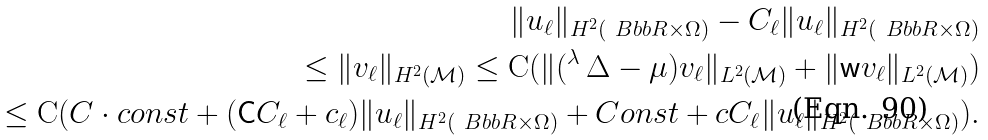<formula> <loc_0><loc_0><loc_500><loc_500>\| u _ { \ell } \| _ { H ^ { 2 } ( \ B b b R \times \Omega ) } - C _ { \ell } \| u _ { \ell } \| _ { H ^ { 2 } ( \ B b b R \times \Omega ) } \\ \leq \| v _ { \ell } \| _ { H ^ { 2 } ( \mathcal { M } ) } \leq \mathrm C ( \| ( { ^ { \lambda } \, \Delta } - \mu ) v _ { \ell } \| _ { L ^ { 2 } ( \mathcal { M } ) } + \| \mathsf w v _ { \ell } \| _ { L ^ { 2 } ( \mathcal { M } ) } ) \\ \leq \mathrm C ( C \cdot c o n s t + ( \mathsf C C _ { \ell } + c _ { \ell } ) \| u _ { \ell } \| _ { H ^ { 2 } ( \ B b b R \times \Omega ) } + C o n s t + c C _ { \ell } \| u _ { \ell } \| _ { H ^ { 2 } ( \ B b b R \times \Omega ) } ) .</formula> 